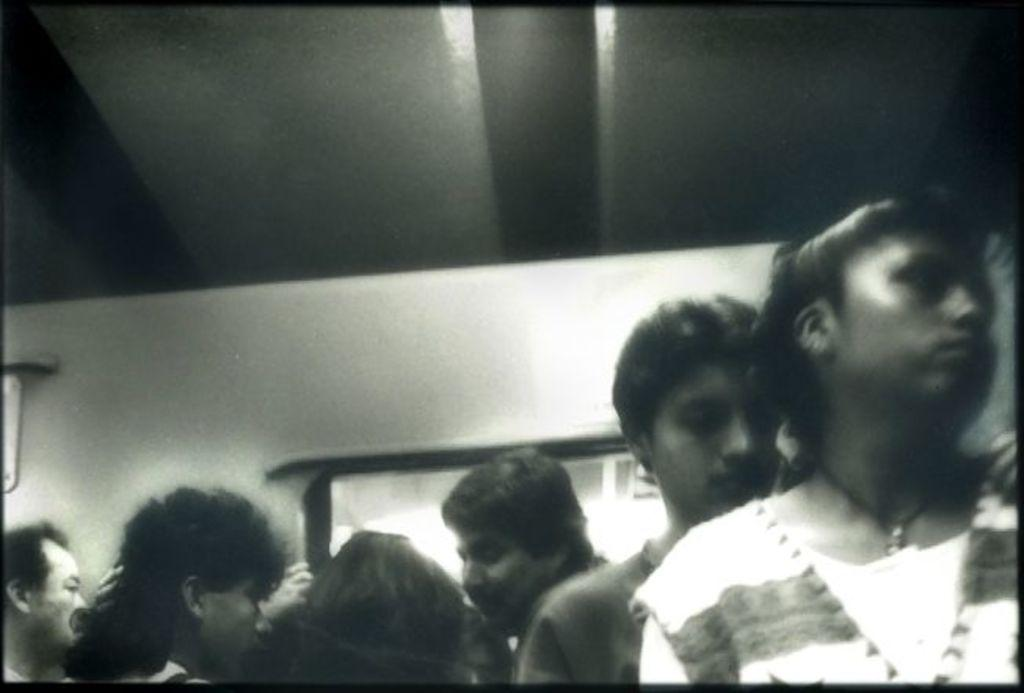What is the color scheme of the image? The image is black and white. Who or what can be seen at the bottom of the image? There are people at the bottom of the image. What is the setting or location of the image? The setting appears to be inside a vehicle. What can be seen behind the people in the image? There is a window visible at the back of the people. What type of wool is being spun by the people in the image? There is no wool or spinning activity present in the image; it is set inside a vehicle with people at the bottom. Can you see any flowers in the image? There are no flowers visible in the image. 